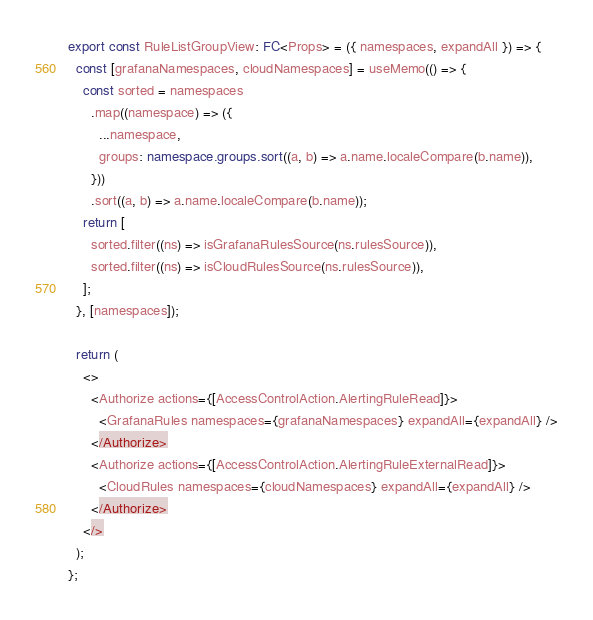<code> <loc_0><loc_0><loc_500><loc_500><_TypeScript_>
export const RuleListGroupView: FC<Props> = ({ namespaces, expandAll }) => {
  const [grafanaNamespaces, cloudNamespaces] = useMemo(() => {
    const sorted = namespaces
      .map((namespace) => ({
        ...namespace,
        groups: namespace.groups.sort((a, b) => a.name.localeCompare(b.name)),
      }))
      .sort((a, b) => a.name.localeCompare(b.name));
    return [
      sorted.filter((ns) => isGrafanaRulesSource(ns.rulesSource)),
      sorted.filter((ns) => isCloudRulesSource(ns.rulesSource)),
    ];
  }, [namespaces]);

  return (
    <>
      <Authorize actions={[AccessControlAction.AlertingRuleRead]}>
        <GrafanaRules namespaces={grafanaNamespaces} expandAll={expandAll} />
      </Authorize>
      <Authorize actions={[AccessControlAction.AlertingRuleExternalRead]}>
        <CloudRules namespaces={cloudNamespaces} expandAll={expandAll} />
      </Authorize>
    </>
  );
};
</code> 